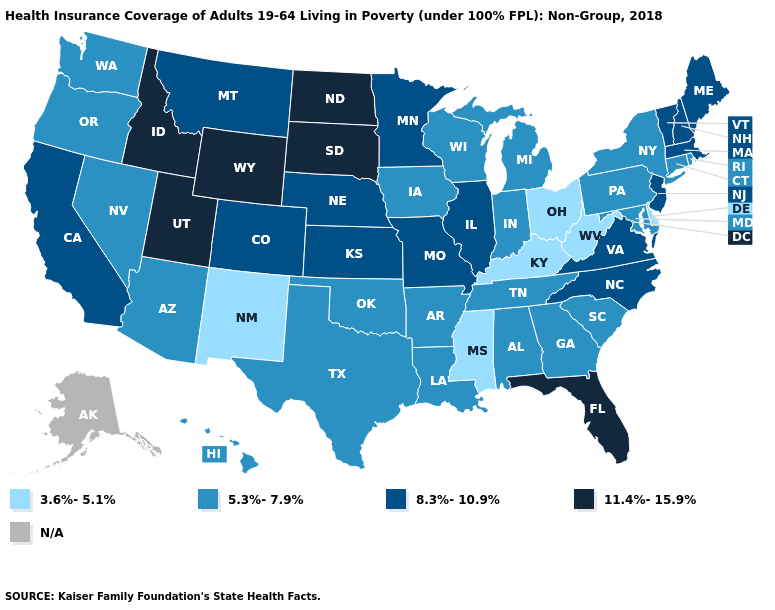What is the value of Colorado?
Quick response, please. 8.3%-10.9%. Does Wyoming have the lowest value in the USA?
Short answer required. No. What is the value of Texas?
Be succinct. 5.3%-7.9%. Which states have the lowest value in the USA?
Concise answer only. Delaware, Kentucky, Mississippi, New Mexico, Ohio, West Virginia. What is the highest value in the USA?
Short answer required. 11.4%-15.9%. What is the value of Indiana?
Short answer required. 5.3%-7.9%. What is the value of Ohio?
Concise answer only. 3.6%-5.1%. What is the value of Maine?
Concise answer only. 8.3%-10.9%. Name the states that have a value in the range 3.6%-5.1%?
Answer briefly. Delaware, Kentucky, Mississippi, New Mexico, Ohio, West Virginia. Does the map have missing data?
Keep it brief. Yes. What is the value of New Hampshire?
Write a very short answer. 8.3%-10.9%. What is the value of New Jersey?
Answer briefly. 8.3%-10.9%. Name the states that have a value in the range 8.3%-10.9%?
Keep it brief. California, Colorado, Illinois, Kansas, Maine, Massachusetts, Minnesota, Missouri, Montana, Nebraska, New Hampshire, New Jersey, North Carolina, Vermont, Virginia. What is the value of South Dakota?
Write a very short answer. 11.4%-15.9%. Which states have the lowest value in the USA?
Answer briefly. Delaware, Kentucky, Mississippi, New Mexico, Ohio, West Virginia. 